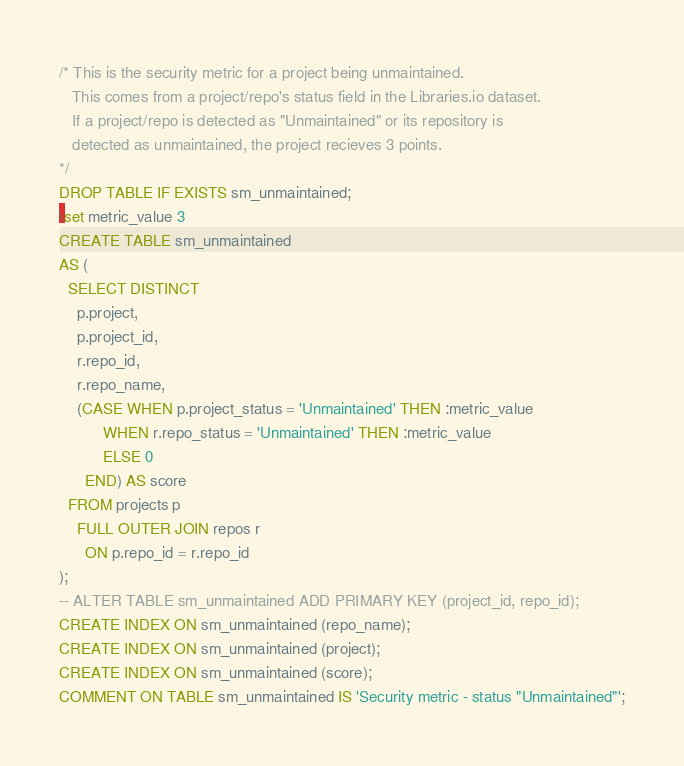Convert code to text. <code><loc_0><loc_0><loc_500><loc_500><_SQL_>/* This is the security metric for a project being unmaintained.
   This comes from a project/repo's status field in the Libraries.io dataset.
   If a project/repo is detected as "Unmaintained" or its repository is
   detected as unmaintained, the project recieves 3 points.
*/
DROP TABLE IF EXISTS sm_unmaintained;
\set metric_value 3
CREATE TABLE sm_unmaintained
AS (
  SELECT DISTINCT
    p.project,
    p.project_id,
    r.repo_id,
    r.repo_name,
    (CASE WHEN p.project_status = 'Unmaintained' THEN :metric_value
          WHEN r.repo_status = 'Unmaintained' THEN :metric_value
          ELSE 0
      END) AS score
  FROM projects p
    FULL OUTER JOIN repos r
      ON p.repo_id = r.repo_id
);
-- ALTER TABLE sm_unmaintained ADD PRIMARY KEY (project_id, repo_id);
CREATE INDEX ON sm_unmaintained (repo_name);
CREATE INDEX ON sm_unmaintained (project);
CREATE INDEX ON sm_unmaintained (score);
COMMENT ON TABLE sm_unmaintained IS 'Security metric - status "Unmaintained"';


</code> 